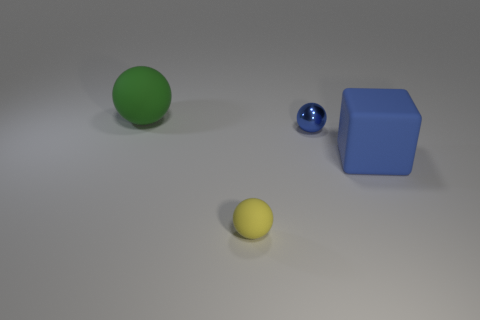What is the large green object made of?
Your answer should be compact. Rubber. Do the metallic sphere and the yellow rubber thing have the same size?
Ensure brevity in your answer.  Yes. How many balls are big blue matte things or small matte things?
Give a very brief answer. 1. What color is the matte ball that is behind the yellow sphere on the left side of the blue sphere?
Ensure brevity in your answer.  Green. Is the number of shiny things on the left side of the tiny yellow sphere less than the number of big blocks to the right of the big green thing?
Provide a succinct answer. Yes. There is a yellow thing; does it have the same size as the blue object that is behind the blue block?
Make the answer very short. Yes. What shape is the object that is both behind the blue matte cube and in front of the green ball?
Keep it short and to the point. Sphere. What size is the blue block that is made of the same material as the large green sphere?
Your answer should be very brief. Large. There is a large object on the right side of the tiny blue ball; how many things are to the left of it?
Ensure brevity in your answer.  3. Are the blue object that is on the right side of the blue metallic thing and the tiny blue sphere made of the same material?
Your response must be concise. No. 